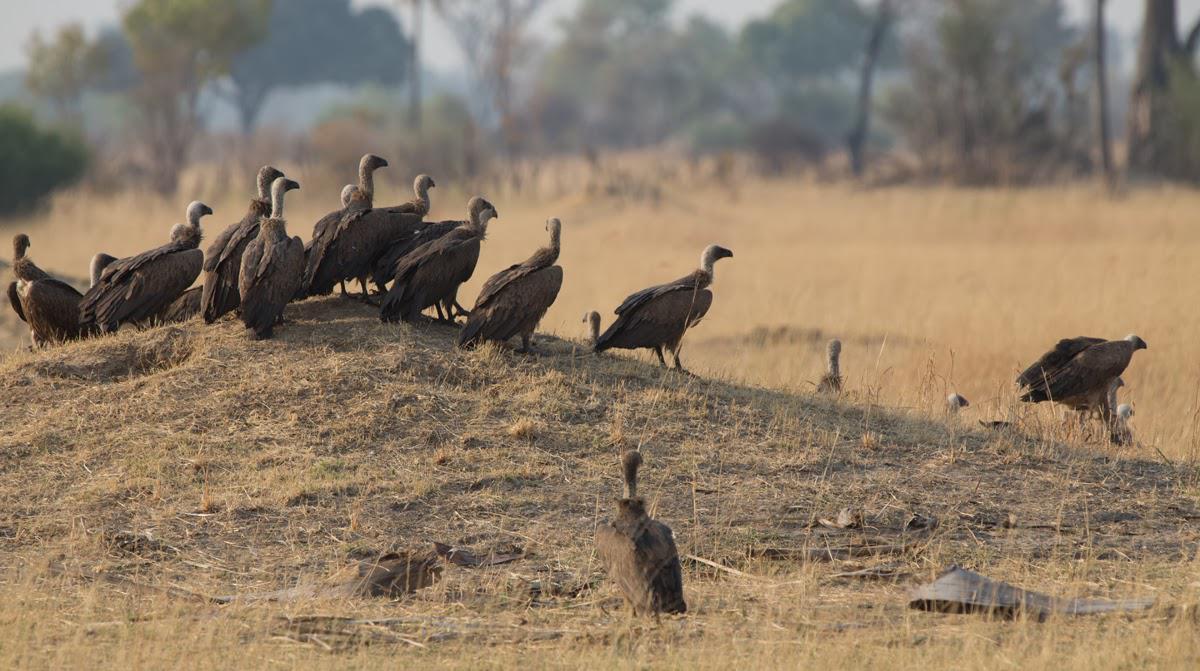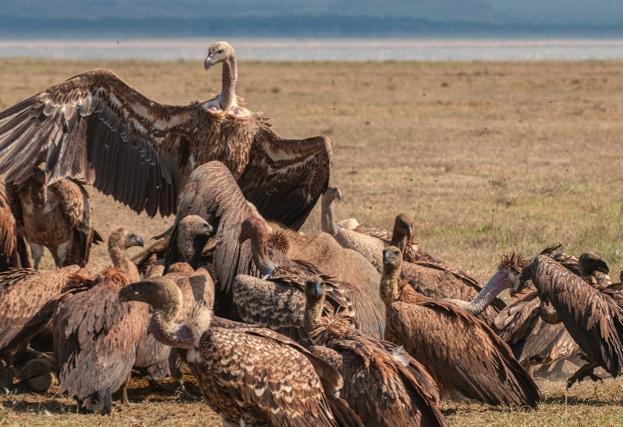The first image is the image on the left, the second image is the image on the right. Examine the images to the left and right. Is the description "It does not appear as though our fine feathered friends are eating right now." accurate? Answer yes or no. No. 